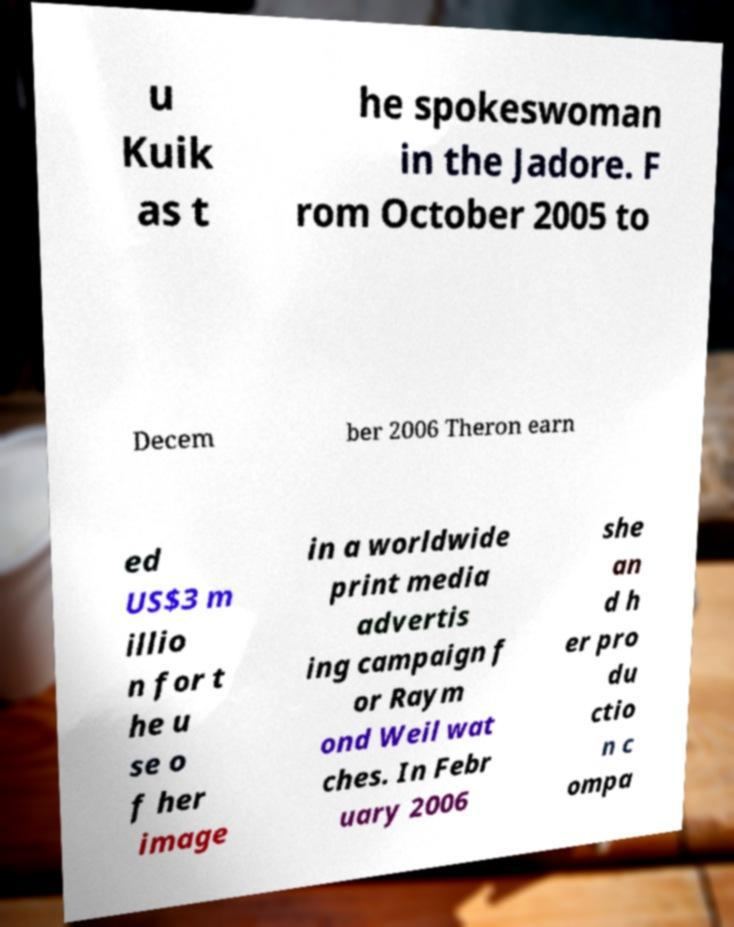Could you assist in decoding the text presented in this image and type it out clearly? u Kuik as t he spokeswoman in the Jadore. F rom October 2005 to Decem ber 2006 Theron earn ed US$3 m illio n for t he u se o f her image in a worldwide print media advertis ing campaign f or Raym ond Weil wat ches. In Febr uary 2006 she an d h er pro du ctio n c ompa 